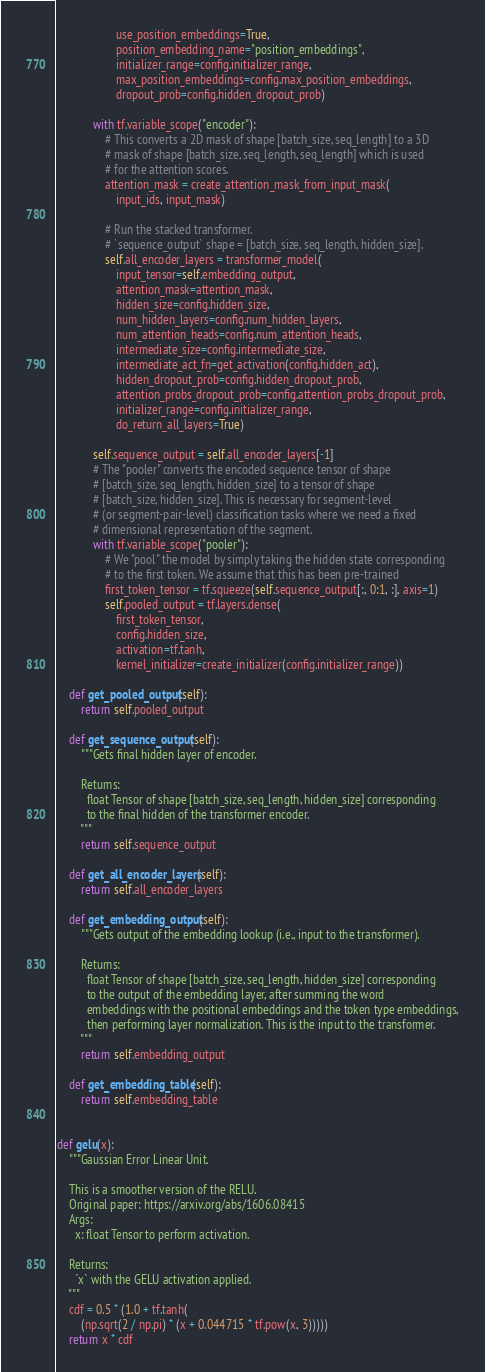<code> <loc_0><loc_0><loc_500><loc_500><_Python_>                    use_position_embeddings=True,
                    position_embedding_name="position_embeddings",
                    initializer_range=config.initializer_range,
                    max_position_embeddings=config.max_position_embeddings,
                    dropout_prob=config.hidden_dropout_prob)

            with tf.variable_scope("encoder"):
                # This converts a 2D mask of shape [batch_size, seq_length] to a 3D
                # mask of shape [batch_size, seq_length, seq_length] which is used
                # for the attention scores.
                attention_mask = create_attention_mask_from_input_mask(
                    input_ids, input_mask)

                # Run the stacked transformer.
                # `sequence_output` shape = [batch_size, seq_length, hidden_size].
                self.all_encoder_layers = transformer_model(
                    input_tensor=self.embedding_output,
                    attention_mask=attention_mask,
                    hidden_size=config.hidden_size,
                    num_hidden_layers=config.num_hidden_layers,
                    num_attention_heads=config.num_attention_heads,
                    intermediate_size=config.intermediate_size,
                    intermediate_act_fn=get_activation(config.hidden_act),
                    hidden_dropout_prob=config.hidden_dropout_prob,
                    attention_probs_dropout_prob=config.attention_probs_dropout_prob,
                    initializer_range=config.initializer_range,
                    do_return_all_layers=True)

            self.sequence_output = self.all_encoder_layers[-1]
            # The "pooler" converts the encoded sequence tensor of shape
            # [batch_size, seq_length, hidden_size] to a tensor of shape
            # [batch_size, hidden_size]. This is necessary for segment-level
            # (or segment-pair-level) classification tasks where we need a fixed
            # dimensional representation of the segment.
            with tf.variable_scope("pooler"):
                # We "pool" the model by simply taking the hidden state corresponding
                # to the first token. We assume that this has been pre-trained
                first_token_tensor = tf.squeeze(self.sequence_output[:, 0:1, :], axis=1)
                self.pooled_output = tf.layers.dense(
                    first_token_tensor,
                    config.hidden_size,
                    activation=tf.tanh,
                    kernel_initializer=create_initializer(config.initializer_range))

    def get_pooled_output(self):
        return self.pooled_output

    def get_sequence_output(self):
        """Gets final hidden layer of encoder.

        Returns:
          float Tensor of shape [batch_size, seq_length, hidden_size] corresponding
          to the final hidden of the transformer encoder.
        """
        return self.sequence_output

    def get_all_encoder_layers(self):
        return self.all_encoder_layers

    def get_embedding_output(self):
        """Gets output of the embedding lookup (i.e., input to the transformer).

        Returns:
          float Tensor of shape [batch_size, seq_length, hidden_size] corresponding
          to the output of the embedding layer, after summing the word
          embeddings with the positional embeddings and the token type embeddings,
          then performing layer normalization. This is the input to the transformer.
        """
        return self.embedding_output

    def get_embedding_table(self):
        return self.embedding_table


def gelu(x):
    """Gaussian Error Linear Unit.

    This is a smoother version of the RELU.
    Original paper: https://arxiv.org/abs/1606.08415
    Args:
      x: float Tensor to perform activation.

    Returns:
      `x` with the GELU activation applied.
    """
    cdf = 0.5 * (1.0 + tf.tanh(
        (np.sqrt(2 / np.pi) * (x + 0.044715 * tf.pow(x, 3)))))
    return x * cdf

</code> 